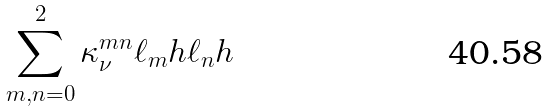<formula> <loc_0><loc_0><loc_500><loc_500>\sum _ { m , n = 0 } ^ { 2 } \kappa _ { \nu } ^ { m n } \ell _ { m } h \ell _ { n } h</formula> 